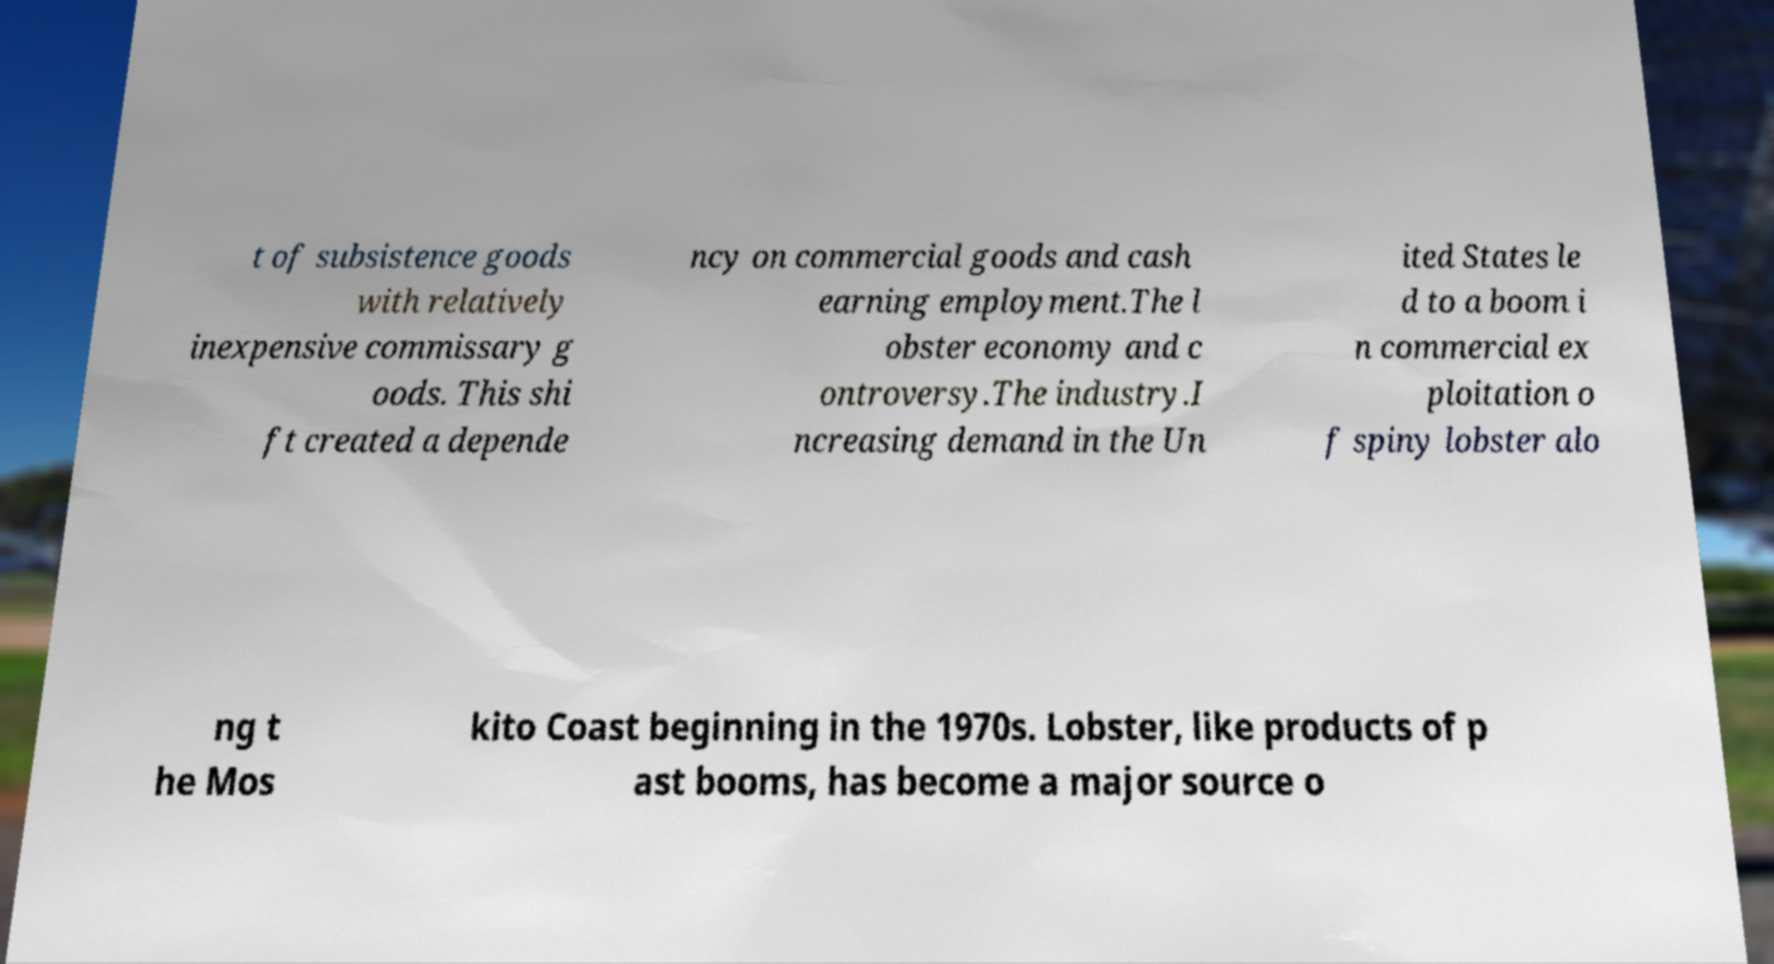Could you assist in decoding the text presented in this image and type it out clearly? t of subsistence goods with relatively inexpensive commissary g oods. This shi ft created a depende ncy on commercial goods and cash earning employment.The l obster economy and c ontroversy.The industry.I ncreasing demand in the Un ited States le d to a boom i n commercial ex ploitation o f spiny lobster alo ng t he Mos kito Coast beginning in the 1970s. Lobster, like products of p ast booms, has become a major source o 